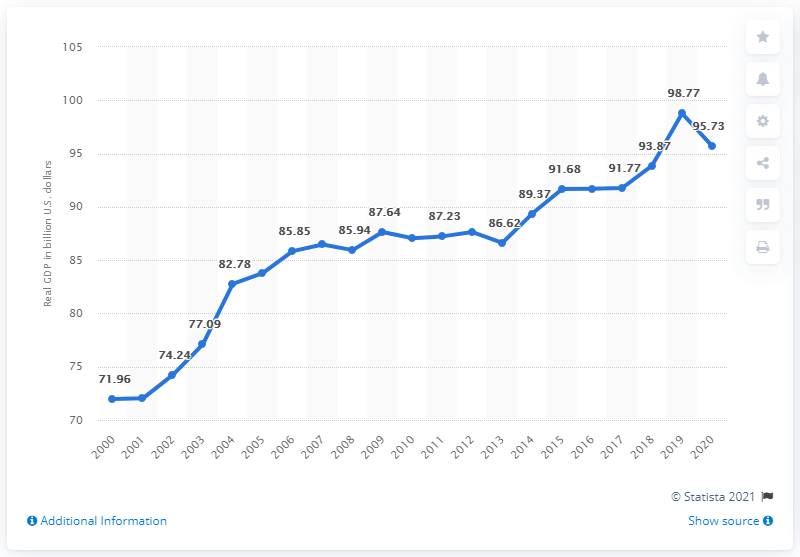Indicate a few pertinent items in this graphic. The previous year's GDP of New Mexico was $98.77 billion dollars. The Gross Domestic Product (GDP) of New Mexico in the year 2020 was 95.73 billion dollars. 